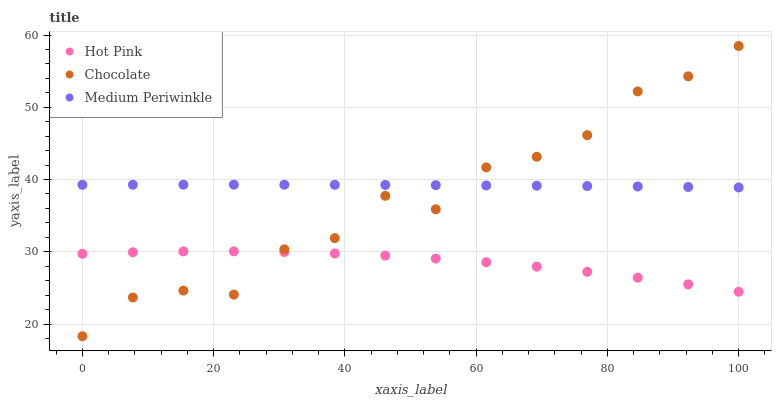Does Hot Pink have the minimum area under the curve?
Answer yes or no. Yes. Does Medium Periwinkle have the maximum area under the curve?
Answer yes or no. Yes. Does Chocolate have the minimum area under the curve?
Answer yes or no. No. Does Chocolate have the maximum area under the curve?
Answer yes or no. No. Is Medium Periwinkle the smoothest?
Answer yes or no. Yes. Is Chocolate the roughest?
Answer yes or no. Yes. Is Chocolate the smoothest?
Answer yes or no. No. Is Medium Periwinkle the roughest?
Answer yes or no. No. Does Chocolate have the lowest value?
Answer yes or no. Yes. Does Medium Periwinkle have the lowest value?
Answer yes or no. No. Does Chocolate have the highest value?
Answer yes or no. Yes. Does Medium Periwinkle have the highest value?
Answer yes or no. No. Is Hot Pink less than Medium Periwinkle?
Answer yes or no. Yes. Is Medium Periwinkle greater than Hot Pink?
Answer yes or no. Yes. Does Chocolate intersect Medium Periwinkle?
Answer yes or no. Yes. Is Chocolate less than Medium Periwinkle?
Answer yes or no. No. Is Chocolate greater than Medium Periwinkle?
Answer yes or no. No. Does Hot Pink intersect Medium Periwinkle?
Answer yes or no. No. 